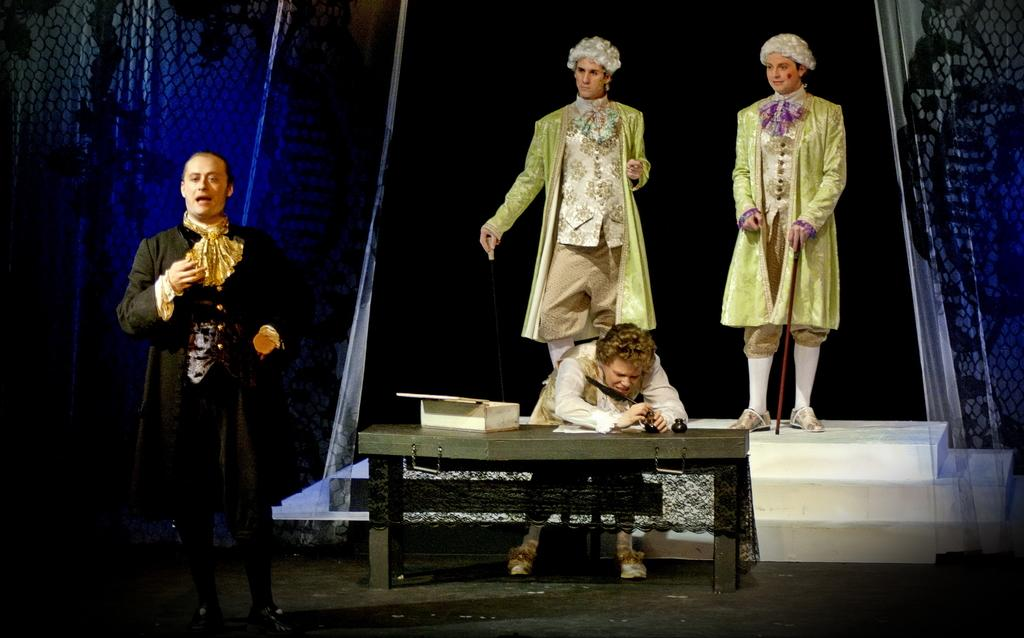How many people are visible in the image? There are persons standing in the image. What is the position of one of the persons in the image? There is a person sitting on a chair in the image. What is located in front of the person sitting on a chair? There is a table in front of the person sitting on a chair. What object is on the table? There is a box on the table. What type of window treatment is present in the image? There are curtains in the image. What type of account is being discussed by the persons in the image? There is no indication in the image that the persons are discussing any accounts. Can you see the moon in the image? The moon is not visible in the image. 